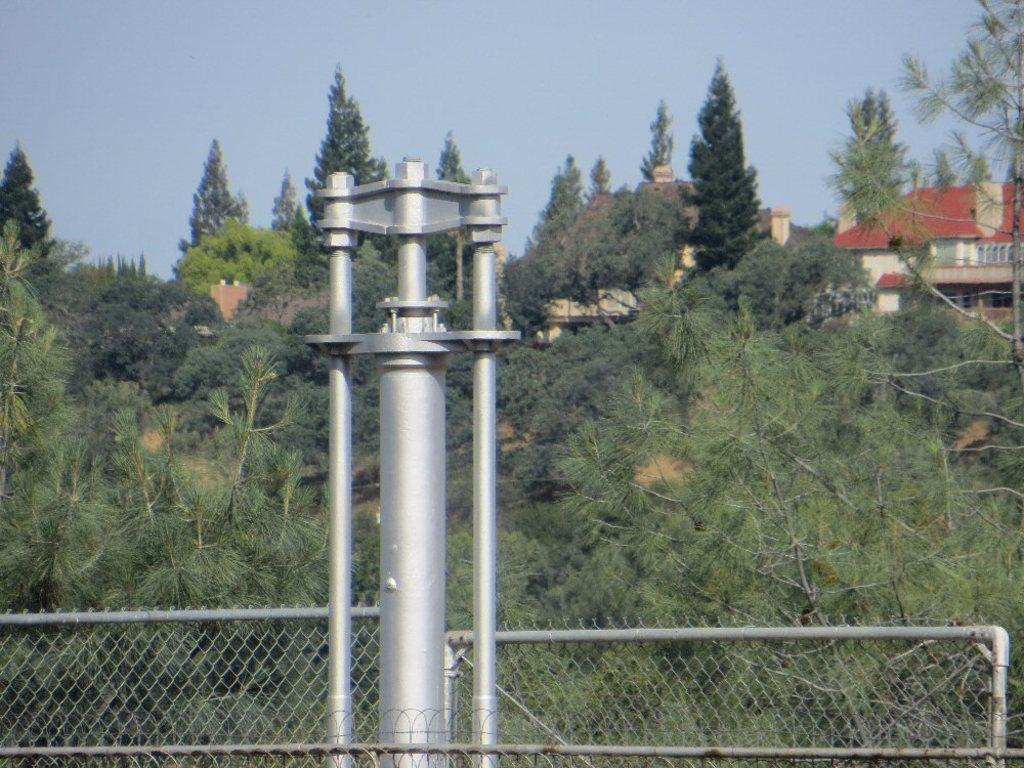What is the main structure in the image? There is a pole in the image. What type of barrier can be seen in the image? There is fencing in the image. What type of vegetation is present in the image? There are trees in the image. What type of man-made structures are visible in the image? There are buildings in the image. What can be seen in the background of the image? The sky is visible in the background of the image. How many sisters are sitting on the car in the image? There is no car or sisters present in the image. 